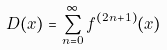Convert formula to latex. <formula><loc_0><loc_0><loc_500><loc_500>D ( x ) = \sum _ { n = 0 } ^ { \infty } f ^ { ( 2 n + 1 ) } ( x )</formula> 